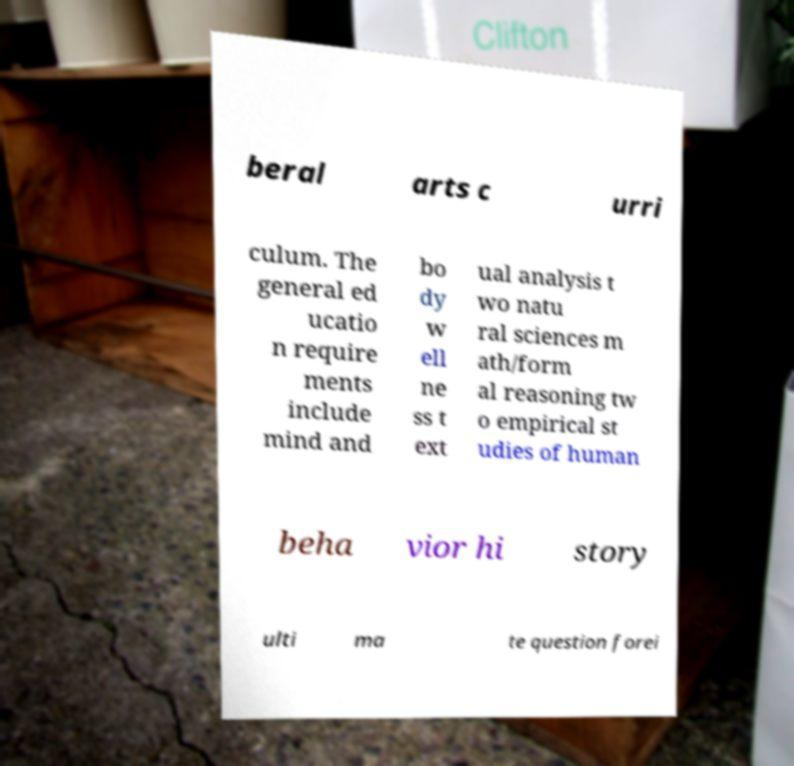Please identify and transcribe the text found in this image. beral arts c urri culum. The general ed ucatio n require ments include mind and bo dy w ell ne ss t ext ual analysis t wo natu ral sciences m ath/form al reasoning tw o empirical st udies of human beha vior hi story ulti ma te question forei 